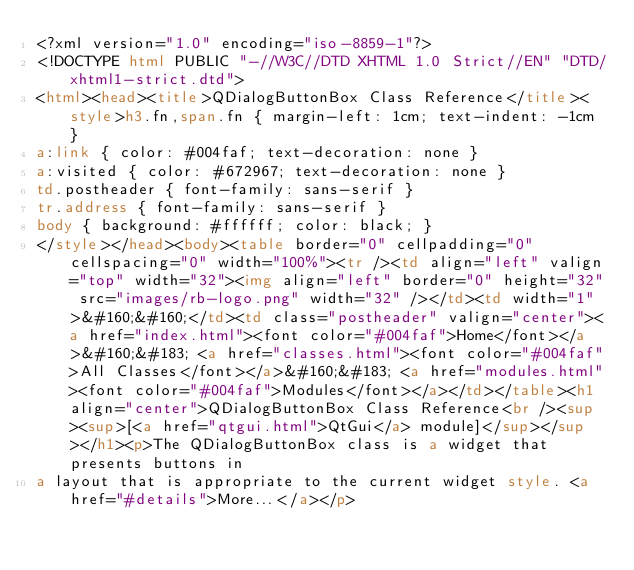<code> <loc_0><loc_0><loc_500><loc_500><_HTML_><?xml version="1.0" encoding="iso-8859-1"?>
<!DOCTYPE html PUBLIC "-//W3C//DTD XHTML 1.0 Strict//EN" "DTD/xhtml1-strict.dtd">
<html><head><title>QDialogButtonBox Class Reference</title><style>h3.fn,span.fn { margin-left: 1cm; text-indent: -1cm }
a:link { color: #004faf; text-decoration: none }
a:visited { color: #672967; text-decoration: none }
td.postheader { font-family: sans-serif }
tr.address { font-family: sans-serif }
body { background: #ffffff; color: black; }
</style></head><body><table border="0" cellpadding="0" cellspacing="0" width="100%"><tr /><td align="left" valign="top" width="32"><img align="left" border="0" height="32" src="images/rb-logo.png" width="32" /></td><td width="1">&#160;&#160;</td><td class="postheader" valign="center"><a href="index.html"><font color="#004faf">Home</font></a>&#160;&#183; <a href="classes.html"><font color="#004faf">All Classes</font></a>&#160;&#183; <a href="modules.html"><font color="#004faf">Modules</font></a></td></table><h1 align="center">QDialogButtonBox Class Reference<br /><sup><sup>[<a href="qtgui.html">QtGui</a> module]</sup></sup></h1><p>The QDialogButtonBox class is a widget that presents buttons in
a layout that is appropriate to the current widget style. <a href="#details">More...</a></p>
</code> 